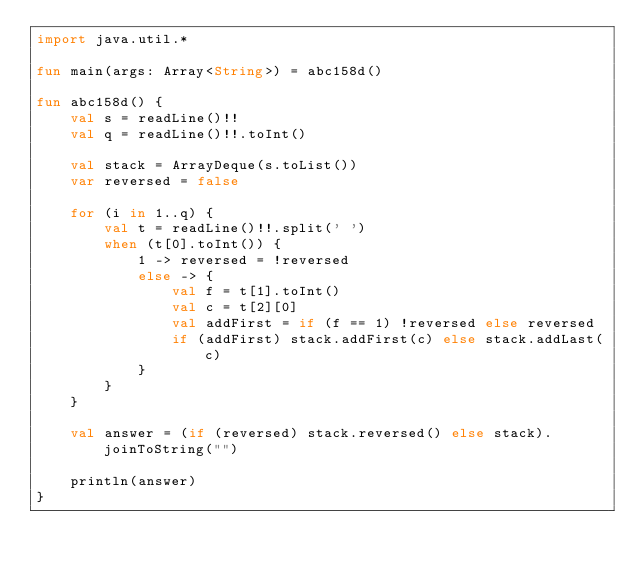Convert code to text. <code><loc_0><loc_0><loc_500><loc_500><_Kotlin_>import java.util.*

fun main(args: Array<String>) = abc158d()

fun abc158d() {
    val s = readLine()!!
    val q = readLine()!!.toInt()

    val stack = ArrayDeque(s.toList())
    var reversed = false

    for (i in 1..q) {
        val t = readLine()!!.split(' ')
        when (t[0].toInt()) {
            1 -> reversed = !reversed
            else -> {
                val f = t[1].toInt()
                val c = t[2][0]
                val addFirst = if (f == 1) !reversed else reversed
                if (addFirst) stack.addFirst(c) else stack.addLast(c)
            }
        }
    }

    val answer = (if (reversed) stack.reversed() else stack).joinToString("")

    println(answer)
}
</code> 